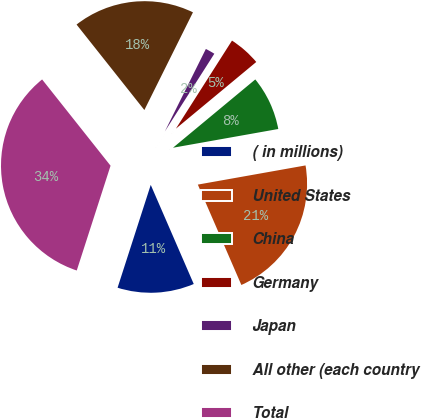Convert chart. <chart><loc_0><loc_0><loc_500><loc_500><pie_chart><fcel>( in millions)<fcel>United States<fcel>China<fcel>Germany<fcel>Japan<fcel>All other (each country<fcel>Total<nl><fcel>11.48%<fcel>21.29%<fcel>8.22%<fcel>4.95%<fcel>1.68%<fcel>18.02%<fcel>34.36%<nl></chart> 